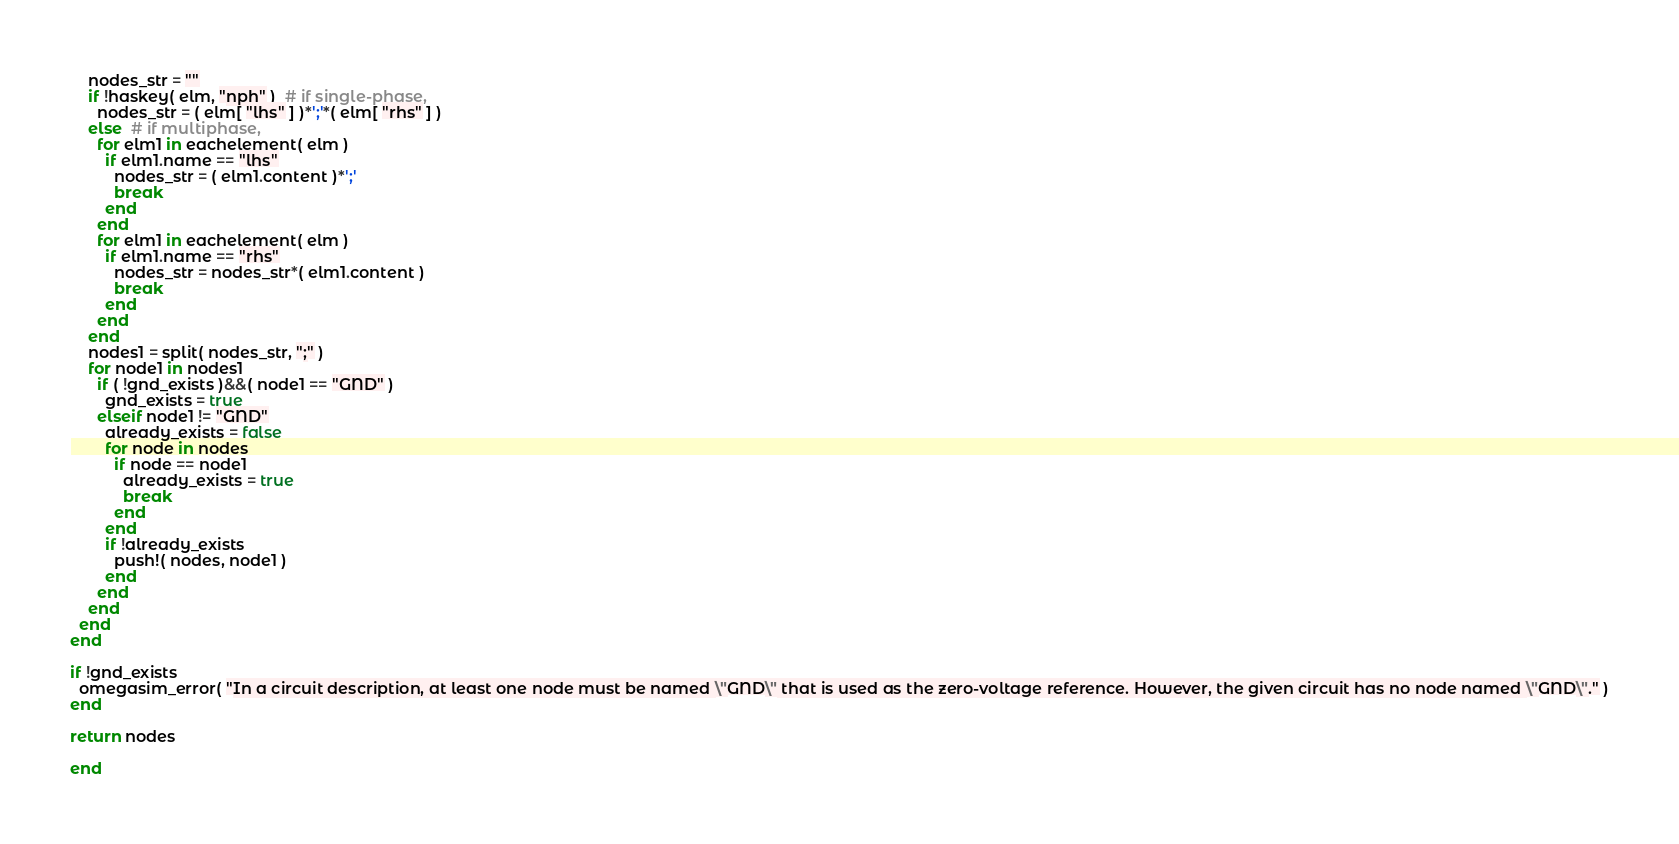Convert code to text. <code><loc_0><loc_0><loc_500><loc_500><_Julia_>    nodes_str = ""
    if !haskey( elm, "nph" )  # if single-phase,
      nodes_str = ( elm[ "lhs" ] )*';'*( elm[ "rhs" ] )
    else  # if multiphase,
      for elm1 in eachelement( elm )
        if elm1.name == "lhs"
          nodes_str = ( elm1.content )*';'
          break
        end
      end
      for elm1 in eachelement( elm )
        if elm1.name == "rhs"
          nodes_str = nodes_str*( elm1.content )
          break
        end
      end
    end
    nodes1 = split( nodes_str, ";" )
    for node1 in nodes1
      if ( !gnd_exists )&&( node1 == "GND" )
        gnd_exists = true
      elseif node1 != "GND"
        already_exists = false
        for node in nodes
          if node == node1
            already_exists = true
            break
          end
        end
        if !already_exists
          push!( nodes, node1 )
        end
      end
    end
  end
end

if !gnd_exists
  omegasim_error( "In a circuit description, at least one node must be named \"GND\" that is used as the zero-voltage reference. However, the given circuit has no node named \"GND\"." )
end

return nodes

end
</code> 